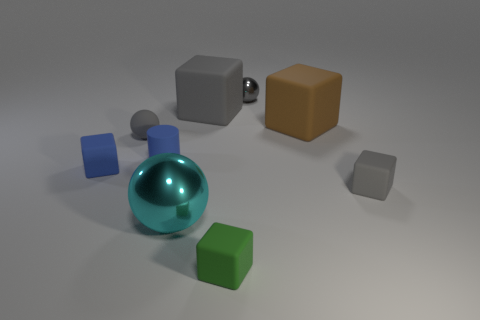Subtract all big gray matte cubes. How many cubes are left? 4 Subtract all green cubes. How many gray spheres are left? 2 Add 1 large blue blocks. How many objects exist? 10 Subtract 2 spheres. How many spheres are left? 1 Subtract all cyan balls. How many balls are left? 2 Subtract all cylinders. How many objects are left? 8 Add 3 small metallic spheres. How many small metallic spheres exist? 4 Subtract 0 blue balls. How many objects are left? 9 Subtract all yellow balls. Subtract all red cylinders. How many balls are left? 3 Subtract all big green cylinders. Subtract all blue rubber cubes. How many objects are left? 8 